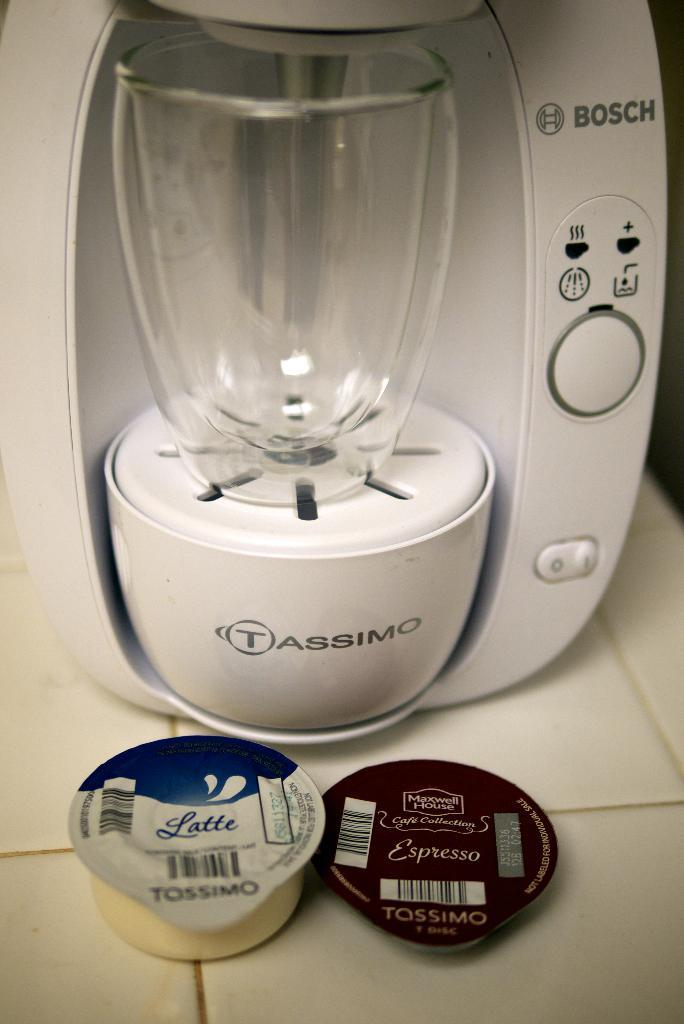<image>
Share a concise interpretation of the image provided. a tassimo machine has a latte pod in front of it 